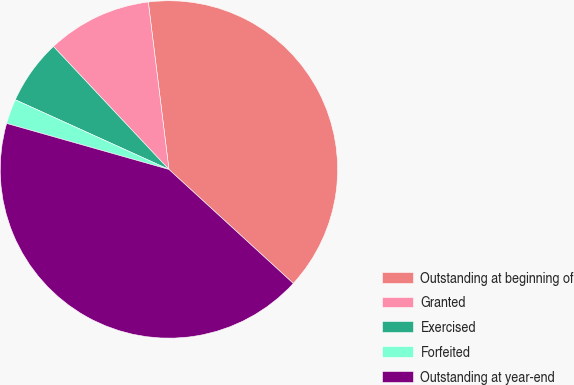Convert chart. <chart><loc_0><loc_0><loc_500><loc_500><pie_chart><fcel>Outstanding at beginning of<fcel>Granted<fcel>Exercised<fcel>Forfeited<fcel>Outstanding at year-end<nl><fcel>38.76%<fcel>10.05%<fcel>6.22%<fcel>2.38%<fcel>42.59%<nl></chart> 